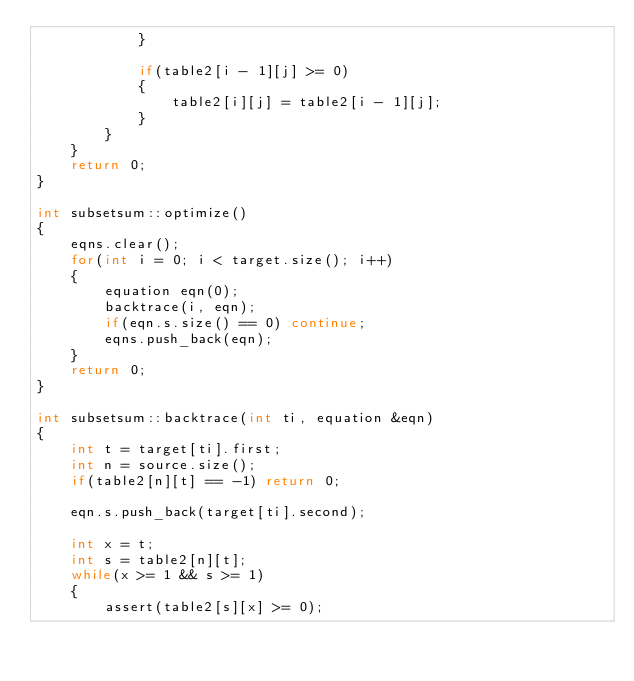<code> <loc_0><loc_0><loc_500><loc_500><_C++_>			}
			
			if(table2[i - 1][j] >= 0)
			{
				table2[i][j] = table2[i - 1][j];
			}
		}
	}
	return 0;
}

int subsetsum::optimize()
{
	eqns.clear();
	for(int i = 0; i < target.size(); i++)
	{
		equation eqn(0);
		backtrace(i, eqn);
		if(eqn.s.size() == 0) continue;
		eqns.push_back(eqn);
	}
	return 0;
}

int subsetsum::backtrace(int ti, equation &eqn)
{
	int t = target[ti].first;
	int n = source.size();
	if(table2[n][t] == -1) return 0;

	eqn.s.push_back(target[ti].second);

	int x = t;
	int s = table2[n][t];
	while(x >= 1 && s >= 1)
	{
		assert(table2[s][x] >= 0);</code> 